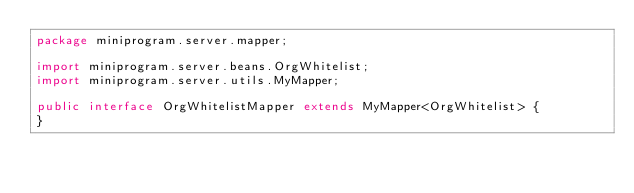<code> <loc_0><loc_0><loc_500><loc_500><_Java_>package miniprogram.server.mapper;

import miniprogram.server.beans.OrgWhitelist;
import miniprogram.server.utils.MyMapper;

public interface OrgWhitelistMapper extends MyMapper<OrgWhitelist> {
}</code> 